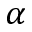<formula> <loc_0><loc_0><loc_500><loc_500>\alpha</formula> 